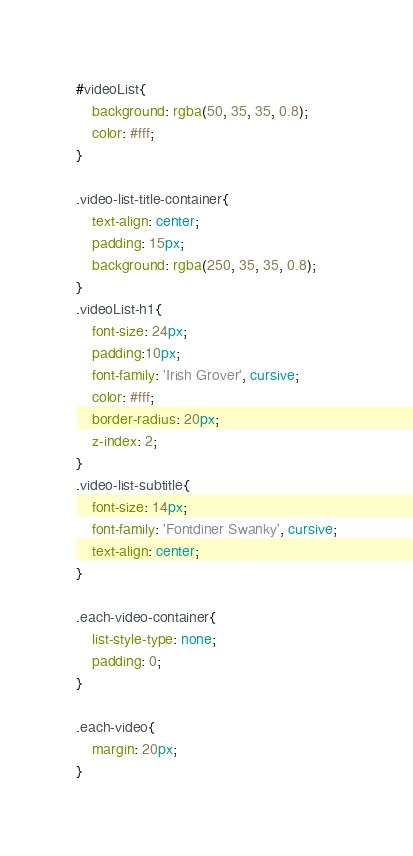<code> <loc_0><loc_0><loc_500><loc_500><_CSS_>#videoList{
	background: rgba(50, 35, 35, 0.8);
	color: #fff;
}

.video-list-title-container{
	text-align: center;
    padding: 15px;
    background: rgba(250, 35, 35, 0.8);
}
.videoList-h1{
	font-size: 24px;
	padding:10px;
	font-family: 'Irish Grover', cursive;
	color: #fff;
	border-radius: 20px;
	z-index: 2;
}
.video-list-subtitle{
	font-size: 14px;
	font-family: 'Fontdiner Swanky', cursive;
	text-align: center;
}

.each-video-container{
	list-style-type: none;
	padding: 0;
}

.each-video{
	margin: 20px;
}</code> 